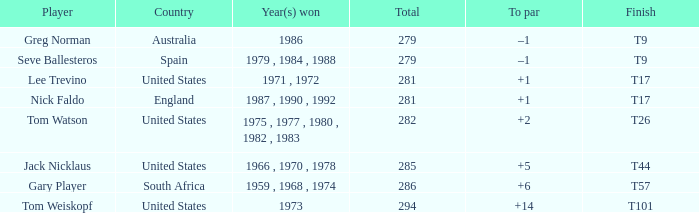What country is Greg Norman from? Australia. 